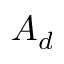Convert formula to latex. <formula><loc_0><loc_0><loc_500><loc_500>A _ { d }</formula> 